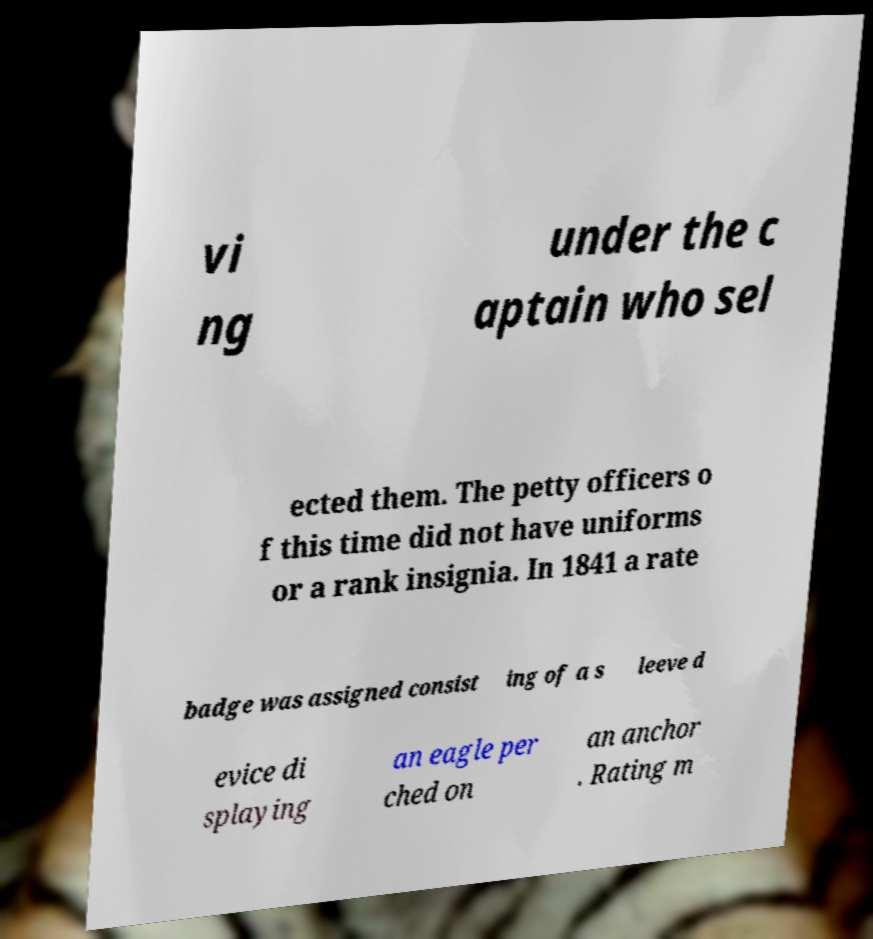For documentation purposes, I need the text within this image transcribed. Could you provide that? vi ng under the c aptain who sel ected them. The petty officers o f this time did not have uniforms or a rank insignia. In 1841 a rate badge was assigned consist ing of a s leeve d evice di splaying an eagle per ched on an anchor . Rating m 